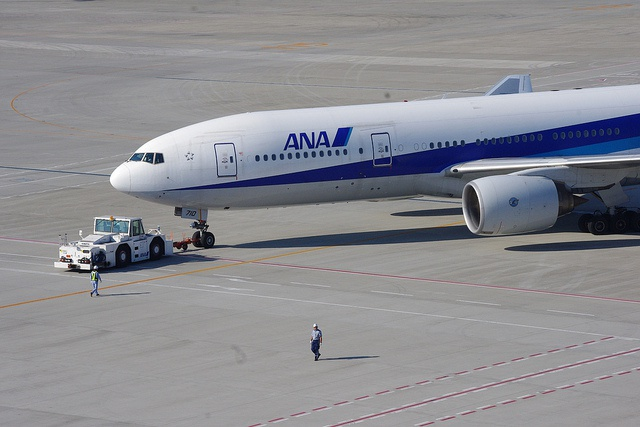Describe the objects in this image and their specific colors. I can see airplane in gray, lightgray, navy, and darkgray tones, truck in gray, black, lightgray, and darkgray tones, people in gray, black, darkgray, and navy tones, and people in gray, black, darkgray, and navy tones in this image. 